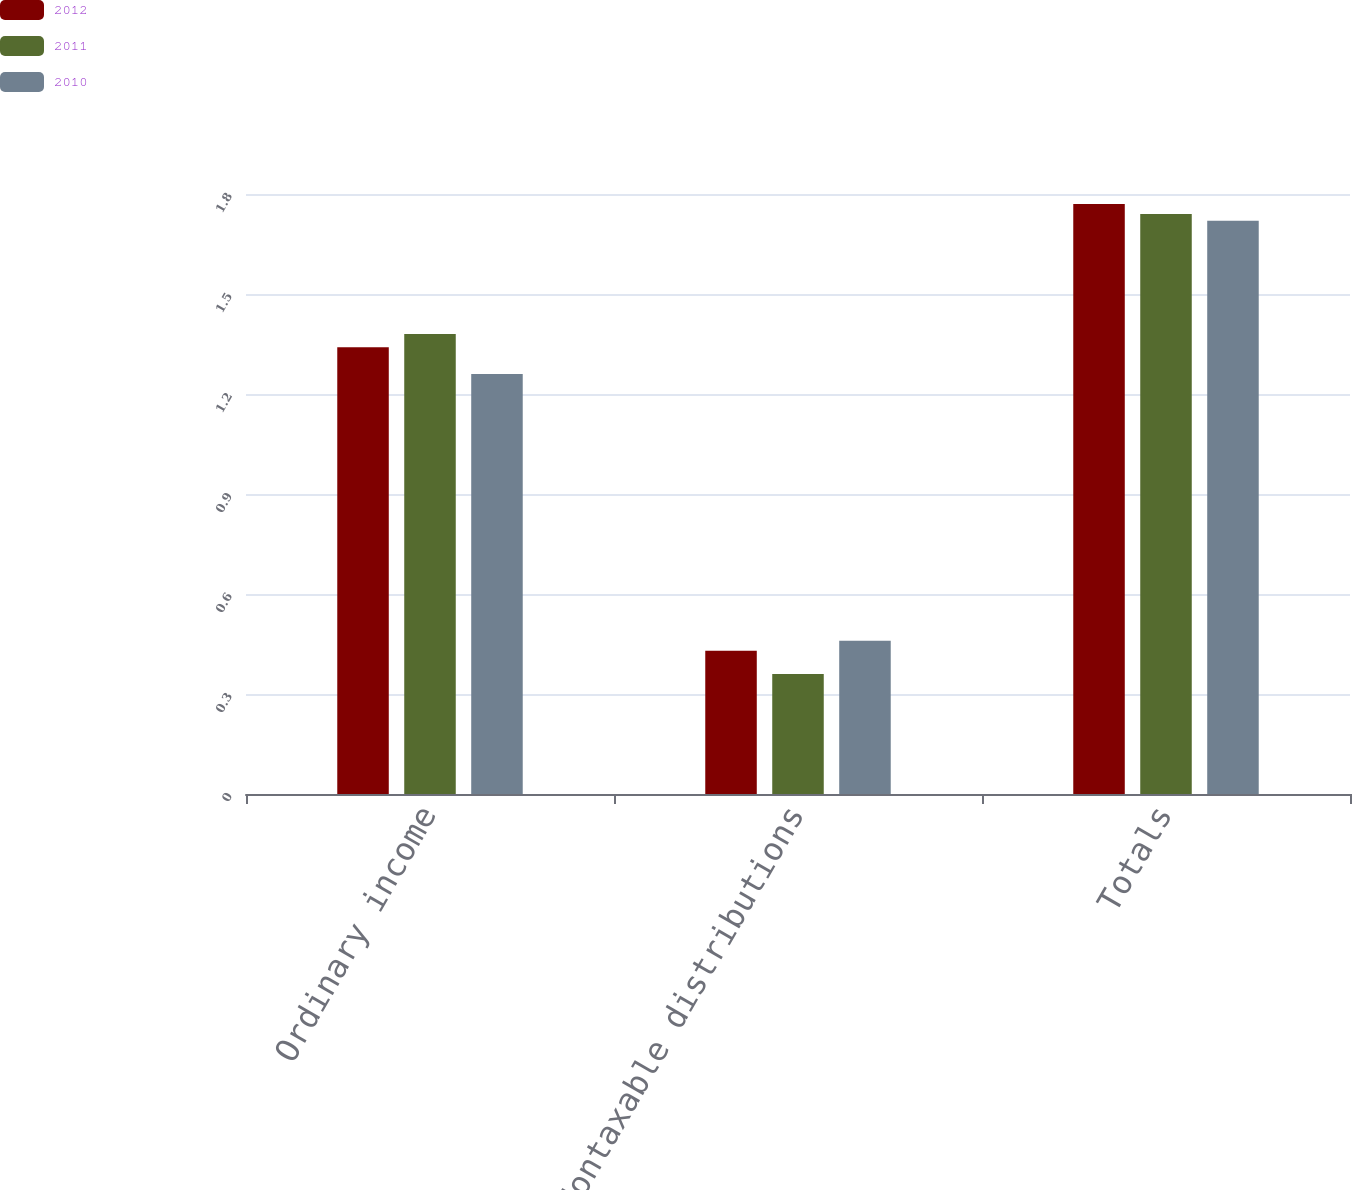Convert chart. <chart><loc_0><loc_0><loc_500><loc_500><stacked_bar_chart><ecel><fcel>Ordinary income<fcel>Nontaxable distributions<fcel>Totals<nl><fcel>2012<fcel>1.34<fcel>0.43<fcel>1.77<nl><fcel>2011<fcel>1.38<fcel>0.36<fcel>1.74<nl><fcel>2010<fcel>1.26<fcel>0.46<fcel>1.72<nl></chart> 